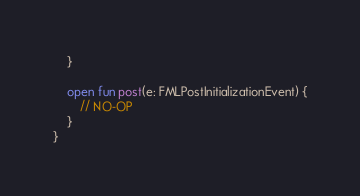Convert code to text. <code><loc_0><loc_0><loc_500><loc_500><_Kotlin_>    }

    open fun post(e: FMLPostInitializationEvent) {
        // NO-OP
    }
}
</code> 